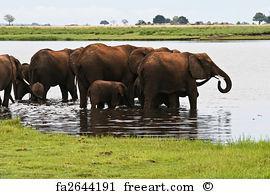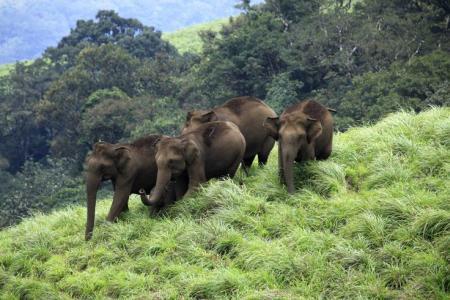The first image is the image on the left, the second image is the image on the right. Given the left and right images, does the statement "The animals in the image on the left are standing in the water." hold true? Answer yes or no. Yes. 